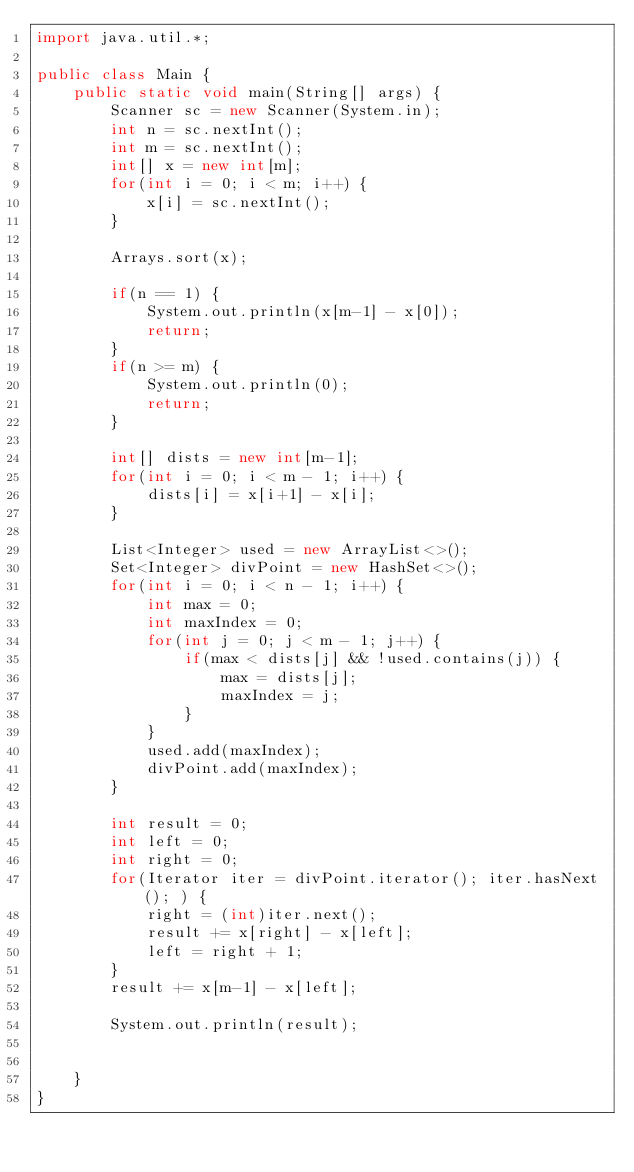<code> <loc_0><loc_0><loc_500><loc_500><_Java_>import java.util.*;

public class Main {
    public static void main(String[] args) {
        Scanner sc = new Scanner(System.in);
        int n = sc.nextInt();
        int m = sc.nextInt();
        int[] x = new int[m];
        for(int i = 0; i < m; i++) {
            x[i] = sc.nextInt();
        }
        
        Arrays.sort(x);
        
        if(n == 1) {
            System.out.println(x[m-1] - x[0]);
            return;
        }
        if(n >= m) {
            System.out.println(0);
            return;
        }
        
        int[] dists = new int[m-1];
        for(int i = 0; i < m - 1; i++) {
            dists[i] = x[i+1] - x[i];
        }
        
        List<Integer> used = new ArrayList<>();
        Set<Integer> divPoint = new HashSet<>();
        for(int i = 0; i < n - 1; i++) {
            int max = 0;
            int maxIndex = 0;
            for(int j = 0; j < m - 1; j++) {
                if(max < dists[j] && !used.contains(j)) {
                    max = dists[j];
                    maxIndex = j;
                }
            }
            used.add(maxIndex);
            divPoint.add(maxIndex);
        }
        
        int result = 0;
        int left = 0;
        int right = 0;
        for(Iterator iter = divPoint.iterator(); iter.hasNext(); ) {
            right = (int)iter.next();
            result += x[right] - x[left];
            left = right + 1;
        }
        result += x[m-1] - x[left];
        
        System.out.println(result);
        
            
    }           
}</code> 